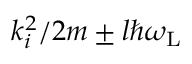Convert formula to latex. <formula><loc_0><loc_0><loc_500><loc_500>k _ { i } ^ { 2 } / 2 m \pm l \hbar { \omega } _ { L }</formula> 